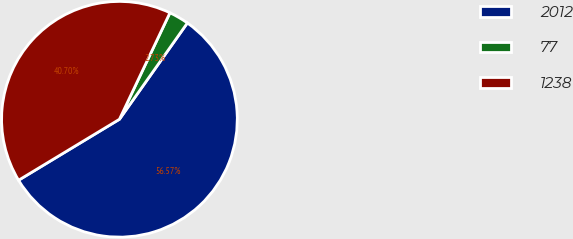<chart> <loc_0><loc_0><loc_500><loc_500><pie_chart><fcel>2012<fcel>77<fcel>1238<nl><fcel>56.57%<fcel>2.73%<fcel>40.7%<nl></chart> 